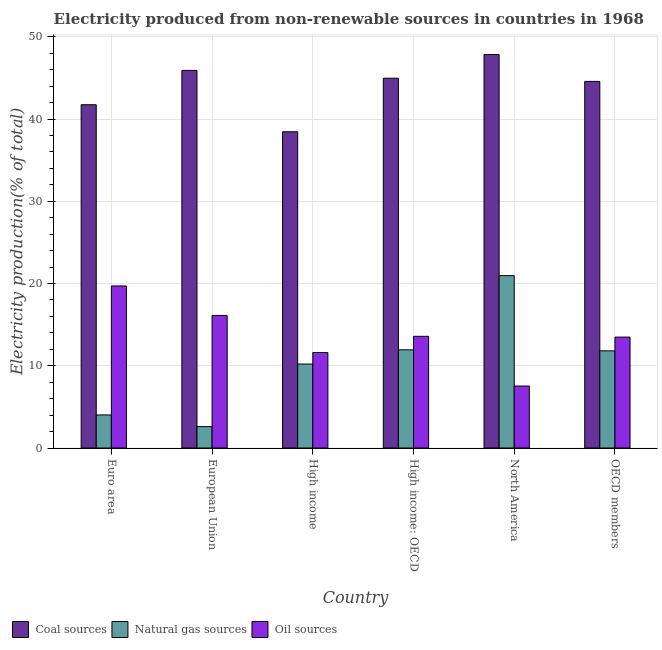How many different coloured bars are there?
Provide a short and direct response. 3. Are the number of bars per tick equal to the number of legend labels?
Offer a terse response. Yes. How many bars are there on the 2nd tick from the left?
Your response must be concise. 3. How many bars are there on the 1st tick from the right?
Your answer should be compact. 3. In how many cases, is the number of bars for a given country not equal to the number of legend labels?
Ensure brevity in your answer.  0. What is the percentage of electricity produced by natural gas in OECD members?
Your answer should be very brief. 11.82. Across all countries, what is the maximum percentage of electricity produced by coal?
Give a very brief answer. 47.84. Across all countries, what is the minimum percentage of electricity produced by natural gas?
Ensure brevity in your answer.  2.6. What is the total percentage of electricity produced by natural gas in the graph?
Offer a very short reply. 61.54. What is the difference between the percentage of electricity produced by coal in Euro area and that in OECD members?
Provide a succinct answer. -2.84. What is the difference between the percentage of electricity produced by coal in High income and the percentage of electricity produced by natural gas in North America?
Make the answer very short. 17.49. What is the average percentage of electricity produced by coal per country?
Give a very brief answer. 43.91. What is the difference between the percentage of electricity produced by oil sources and percentage of electricity produced by coal in High income: OECD?
Keep it short and to the point. -31.38. What is the ratio of the percentage of electricity produced by coal in North America to that in OECD members?
Give a very brief answer. 1.07. What is the difference between the highest and the second highest percentage of electricity produced by oil sources?
Make the answer very short. 3.59. What is the difference between the highest and the lowest percentage of electricity produced by natural gas?
Give a very brief answer. 18.35. What does the 1st bar from the left in High income: OECD represents?
Make the answer very short. Coal sources. What does the 2nd bar from the right in North America represents?
Provide a short and direct response. Natural gas sources. Is it the case that in every country, the sum of the percentage of electricity produced by coal and percentage of electricity produced by natural gas is greater than the percentage of electricity produced by oil sources?
Provide a short and direct response. Yes. How many countries are there in the graph?
Your answer should be very brief. 6. Are the values on the major ticks of Y-axis written in scientific E-notation?
Give a very brief answer. No. Where does the legend appear in the graph?
Give a very brief answer. Bottom left. How many legend labels are there?
Your response must be concise. 3. What is the title of the graph?
Offer a very short reply. Electricity produced from non-renewable sources in countries in 1968. What is the label or title of the Y-axis?
Give a very brief answer. Electricity production(% of total). What is the Electricity production(% of total) in Coal sources in Euro area?
Your answer should be compact. 41.74. What is the Electricity production(% of total) of Natural gas sources in Euro area?
Your response must be concise. 4.02. What is the Electricity production(% of total) of Oil sources in Euro area?
Ensure brevity in your answer.  19.7. What is the Electricity production(% of total) of Coal sources in European Union?
Provide a short and direct response. 45.91. What is the Electricity production(% of total) of Natural gas sources in European Union?
Keep it short and to the point. 2.6. What is the Electricity production(% of total) of Oil sources in European Union?
Offer a very short reply. 16.12. What is the Electricity production(% of total) of Coal sources in High income?
Keep it short and to the point. 38.45. What is the Electricity production(% of total) of Natural gas sources in High income?
Keep it short and to the point. 10.21. What is the Electricity production(% of total) of Oil sources in High income?
Your answer should be compact. 11.61. What is the Electricity production(% of total) in Coal sources in High income: OECD?
Give a very brief answer. 44.96. What is the Electricity production(% of total) of Natural gas sources in High income: OECD?
Give a very brief answer. 11.94. What is the Electricity production(% of total) in Oil sources in High income: OECD?
Your response must be concise. 13.58. What is the Electricity production(% of total) of Coal sources in North America?
Ensure brevity in your answer.  47.84. What is the Electricity production(% of total) in Natural gas sources in North America?
Offer a terse response. 20.96. What is the Electricity production(% of total) of Oil sources in North America?
Provide a succinct answer. 7.54. What is the Electricity production(% of total) of Coal sources in OECD members?
Your answer should be compact. 44.57. What is the Electricity production(% of total) in Natural gas sources in OECD members?
Provide a succinct answer. 11.82. What is the Electricity production(% of total) of Oil sources in OECD members?
Keep it short and to the point. 13.48. Across all countries, what is the maximum Electricity production(% of total) in Coal sources?
Ensure brevity in your answer.  47.84. Across all countries, what is the maximum Electricity production(% of total) in Natural gas sources?
Your answer should be compact. 20.96. Across all countries, what is the maximum Electricity production(% of total) in Oil sources?
Keep it short and to the point. 19.7. Across all countries, what is the minimum Electricity production(% of total) in Coal sources?
Give a very brief answer. 38.45. Across all countries, what is the minimum Electricity production(% of total) of Natural gas sources?
Your answer should be compact. 2.6. Across all countries, what is the minimum Electricity production(% of total) in Oil sources?
Offer a terse response. 7.54. What is the total Electricity production(% of total) in Coal sources in the graph?
Offer a terse response. 263.48. What is the total Electricity production(% of total) of Natural gas sources in the graph?
Your response must be concise. 61.54. What is the total Electricity production(% of total) in Oil sources in the graph?
Your answer should be compact. 82.03. What is the difference between the Electricity production(% of total) in Coal sources in Euro area and that in European Union?
Give a very brief answer. -4.17. What is the difference between the Electricity production(% of total) of Natural gas sources in Euro area and that in European Union?
Give a very brief answer. 1.42. What is the difference between the Electricity production(% of total) of Oil sources in Euro area and that in European Union?
Make the answer very short. 3.59. What is the difference between the Electricity production(% of total) in Coal sources in Euro area and that in High income?
Keep it short and to the point. 3.29. What is the difference between the Electricity production(% of total) of Natural gas sources in Euro area and that in High income?
Keep it short and to the point. -6.19. What is the difference between the Electricity production(% of total) of Oil sources in Euro area and that in High income?
Offer a very short reply. 8.09. What is the difference between the Electricity production(% of total) in Coal sources in Euro area and that in High income: OECD?
Your answer should be compact. -3.22. What is the difference between the Electricity production(% of total) in Natural gas sources in Euro area and that in High income: OECD?
Offer a very short reply. -7.92. What is the difference between the Electricity production(% of total) of Oil sources in Euro area and that in High income: OECD?
Your response must be concise. 6.12. What is the difference between the Electricity production(% of total) of Coal sources in Euro area and that in North America?
Ensure brevity in your answer.  -6.1. What is the difference between the Electricity production(% of total) of Natural gas sources in Euro area and that in North America?
Ensure brevity in your answer.  -16.94. What is the difference between the Electricity production(% of total) in Oil sources in Euro area and that in North America?
Your response must be concise. 12.17. What is the difference between the Electricity production(% of total) of Coal sources in Euro area and that in OECD members?
Give a very brief answer. -2.84. What is the difference between the Electricity production(% of total) of Natural gas sources in Euro area and that in OECD members?
Provide a short and direct response. -7.8. What is the difference between the Electricity production(% of total) of Oil sources in Euro area and that in OECD members?
Make the answer very short. 6.22. What is the difference between the Electricity production(% of total) in Coal sources in European Union and that in High income?
Give a very brief answer. 7.46. What is the difference between the Electricity production(% of total) in Natural gas sources in European Union and that in High income?
Ensure brevity in your answer.  -7.61. What is the difference between the Electricity production(% of total) of Oil sources in European Union and that in High income?
Offer a very short reply. 4.5. What is the difference between the Electricity production(% of total) in Coal sources in European Union and that in High income: OECD?
Provide a short and direct response. 0.95. What is the difference between the Electricity production(% of total) of Natural gas sources in European Union and that in High income: OECD?
Ensure brevity in your answer.  -9.34. What is the difference between the Electricity production(% of total) in Oil sources in European Union and that in High income: OECD?
Offer a terse response. 2.54. What is the difference between the Electricity production(% of total) of Coal sources in European Union and that in North America?
Provide a short and direct response. -1.93. What is the difference between the Electricity production(% of total) of Natural gas sources in European Union and that in North America?
Your answer should be compact. -18.35. What is the difference between the Electricity production(% of total) in Oil sources in European Union and that in North America?
Your response must be concise. 8.58. What is the difference between the Electricity production(% of total) of Coal sources in European Union and that in OECD members?
Provide a short and direct response. 1.34. What is the difference between the Electricity production(% of total) in Natural gas sources in European Union and that in OECD members?
Your response must be concise. -9.21. What is the difference between the Electricity production(% of total) in Oil sources in European Union and that in OECD members?
Give a very brief answer. 2.63. What is the difference between the Electricity production(% of total) in Coal sources in High income and that in High income: OECD?
Offer a terse response. -6.51. What is the difference between the Electricity production(% of total) of Natural gas sources in High income and that in High income: OECD?
Your answer should be very brief. -1.73. What is the difference between the Electricity production(% of total) of Oil sources in High income and that in High income: OECD?
Make the answer very short. -1.97. What is the difference between the Electricity production(% of total) in Coal sources in High income and that in North America?
Your response must be concise. -9.39. What is the difference between the Electricity production(% of total) in Natural gas sources in High income and that in North America?
Your response must be concise. -10.75. What is the difference between the Electricity production(% of total) of Oil sources in High income and that in North America?
Ensure brevity in your answer.  4.08. What is the difference between the Electricity production(% of total) of Coal sources in High income and that in OECD members?
Make the answer very short. -6.12. What is the difference between the Electricity production(% of total) of Natural gas sources in High income and that in OECD members?
Give a very brief answer. -1.61. What is the difference between the Electricity production(% of total) of Oil sources in High income and that in OECD members?
Provide a short and direct response. -1.87. What is the difference between the Electricity production(% of total) of Coal sources in High income: OECD and that in North America?
Keep it short and to the point. -2.88. What is the difference between the Electricity production(% of total) of Natural gas sources in High income: OECD and that in North America?
Keep it short and to the point. -9.02. What is the difference between the Electricity production(% of total) in Oil sources in High income: OECD and that in North America?
Provide a short and direct response. 6.04. What is the difference between the Electricity production(% of total) of Coal sources in High income: OECD and that in OECD members?
Offer a very short reply. 0.39. What is the difference between the Electricity production(% of total) in Natural gas sources in High income: OECD and that in OECD members?
Your answer should be very brief. 0.12. What is the difference between the Electricity production(% of total) of Oil sources in High income: OECD and that in OECD members?
Offer a very short reply. 0.1. What is the difference between the Electricity production(% of total) in Coal sources in North America and that in OECD members?
Make the answer very short. 3.27. What is the difference between the Electricity production(% of total) in Natural gas sources in North America and that in OECD members?
Keep it short and to the point. 9.14. What is the difference between the Electricity production(% of total) in Oil sources in North America and that in OECD members?
Your answer should be compact. -5.95. What is the difference between the Electricity production(% of total) of Coal sources in Euro area and the Electricity production(% of total) of Natural gas sources in European Union?
Provide a succinct answer. 39.14. What is the difference between the Electricity production(% of total) of Coal sources in Euro area and the Electricity production(% of total) of Oil sources in European Union?
Keep it short and to the point. 25.62. What is the difference between the Electricity production(% of total) of Natural gas sources in Euro area and the Electricity production(% of total) of Oil sources in European Union?
Your response must be concise. -12.1. What is the difference between the Electricity production(% of total) of Coal sources in Euro area and the Electricity production(% of total) of Natural gas sources in High income?
Offer a terse response. 31.53. What is the difference between the Electricity production(% of total) of Coal sources in Euro area and the Electricity production(% of total) of Oil sources in High income?
Your answer should be compact. 30.13. What is the difference between the Electricity production(% of total) of Natural gas sources in Euro area and the Electricity production(% of total) of Oil sources in High income?
Your answer should be compact. -7.59. What is the difference between the Electricity production(% of total) of Coal sources in Euro area and the Electricity production(% of total) of Natural gas sources in High income: OECD?
Your response must be concise. 29.8. What is the difference between the Electricity production(% of total) of Coal sources in Euro area and the Electricity production(% of total) of Oil sources in High income: OECD?
Your answer should be very brief. 28.16. What is the difference between the Electricity production(% of total) in Natural gas sources in Euro area and the Electricity production(% of total) in Oil sources in High income: OECD?
Give a very brief answer. -9.56. What is the difference between the Electricity production(% of total) of Coal sources in Euro area and the Electricity production(% of total) of Natural gas sources in North America?
Offer a very short reply. 20.78. What is the difference between the Electricity production(% of total) of Coal sources in Euro area and the Electricity production(% of total) of Oil sources in North America?
Give a very brief answer. 34.2. What is the difference between the Electricity production(% of total) in Natural gas sources in Euro area and the Electricity production(% of total) in Oil sources in North America?
Your answer should be compact. -3.52. What is the difference between the Electricity production(% of total) in Coal sources in Euro area and the Electricity production(% of total) in Natural gas sources in OECD members?
Ensure brevity in your answer.  29.92. What is the difference between the Electricity production(% of total) of Coal sources in Euro area and the Electricity production(% of total) of Oil sources in OECD members?
Your answer should be very brief. 28.25. What is the difference between the Electricity production(% of total) in Natural gas sources in Euro area and the Electricity production(% of total) in Oil sources in OECD members?
Offer a very short reply. -9.47. What is the difference between the Electricity production(% of total) in Coal sources in European Union and the Electricity production(% of total) in Natural gas sources in High income?
Your response must be concise. 35.7. What is the difference between the Electricity production(% of total) in Coal sources in European Union and the Electricity production(% of total) in Oil sources in High income?
Your answer should be compact. 34.3. What is the difference between the Electricity production(% of total) of Natural gas sources in European Union and the Electricity production(% of total) of Oil sources in High income?
Make the answer very short. -9.01. What is the difference between the Electricity production(% of total) of Coal sources in European Union and the Electricity production(% of total) of Natural gas sources in High income: OECD?
Your response must be concise. 33.97. What is the difference between the Electricity production(% of total) in Coal sources in European Union and the Electricity production(% of total) in Oil sources in High income: OECD?
Offer a very short reply. 32.33. What is the difference between the Electricity production(% of total) in Natural gas sources in European Union and the Electricity production(% of total) in Oil sources in High income: OECD?
Your response must be concise. -10.98. What is the difference between the Electricity production(% of total) of Coal sources in European Union and the Electricity production(% of total) of Natural gas sources in North America?
Keep it short and to the point. 24.95. What is the difference between the Electricity production(% of total) of Coal sources in European Union and the Electricity production(% of total) of Oil sources in North America?
Your response must be concise. 38.38. What is the difference between the Electricity production(% of total) of Natural gas sources in European Union and the Electricity production(% of total) of Oil sources in North America?
Your answer should be very brief. -4.93. What is the difference between the Electricity production(% of total) of Coal sources in European Union and the Electricity production(% of total) of Natural gas sources in OECD members?
Keep it short and to the point. 34.1. What is the difference between the Electricity production(% of total) in Coal sources in European Union and the Electricity production(% of total) in Oil sources in OECD members?
Provide a short and direct response. 32.43. What is the difference between the Electricity production(% of total) in Natural gas sources in European Union and the Electricity production(% of total) in Oil sources in OECD members?
Provide a succinct answer. -10.88. What is the difference between the Electricity production(% of total) of Coal sources in High income and the Electricity production(% of total) of Natural gas sources in High income: OECD?
Ensure brevity in your answer.  26.51. What is the difference between the Electricity production(% of total) of Coal sources in High income and the Electricity production(% of total) of Oil sources in High income: OECD?
Your answer should be very brief. 24.87. What is the difference between the Electricity production(% of total) of Natural gas sources in High income and the Electricity production(% of total) of Oil sources in High income: OECD?
Offer a terse response. -3.37. What is the difference between the Electricity production(% of total) in Coal sources in High income and the Electricity production(% of total) in Natural gas sources in North America?
Your answer should be compact. 17.49. What is the difference between the Electricity production(% of total) in Coal sources in High income and the Electricity production(% of total) in Oil sources in North America?
Provide a short and direct response. 30.91. What is the difference between the Electricity production(% of total) in Natural gas sources in High income and the Electricity production(% of total) in Oil sources in North America?
Your answer should be very brief. 2.67. What is the difference between the Electricity production(% of total) of Coal sources in High income and the Electricity production(% of total) of Natural gas sources in OECD members?
Offer a terse response. 26.63. What is the difference between the Electricity production(% of total) of Coal sources in High income and the Electricity production(% of total) of Oil sources in OECD members?
Your response must be concise. 24.96. What is the difference between the Electricity production(% of total) in Natural gas sources in High income and the Electricity production(% of total) in Oil sources in OECD members?
Offer a very short reply. -3.28. What is the difference between the Electricity production(% of total) of Coal sources in High income: OECD and the Electricity production(% of total) of Natural gas sources in North America?
Provide a succinct answer. 24.01. What is the difference between the Electricity production(% of total) in Coal sources in High income: OECD and the Electricity production(% of total) in Oil sources in North America?
Provide a succinct answer. 37.43. What is the difference between the Electricity production(% of total) of Natural gas sources in High income: OECD and the Electricity production(% of total) of Oil sources in North America?
Offer a terse response. 4.4. What is the difference between the Electricity production(% of total) of Coal sources in High income: OECD and the Electricity production(% of total) of Natural gas sources in OECD members?
Your response must be concise. 33.15. What is the difference between the Electricity production(% of total) of Coal sources in High income: OECD and the Electricity production(% of total) of Oil sources in OECD members?
Provide a succinct answer. 31.48. What is the difference between the Electricity production(% of total) of Natural gas sources in High income: OECD and the Electricity production(% of total) of Oil sources in OECD members?
Provide a short and direct response. -1.55. What is the difference between the Electricity production(% of total) of Coal sources in North America and the Electricity production(% of total) of Natural gas sources in OECD members?
Give a very brief answer. 36.02. What is the difference between the Electricity production(% of total) of Coal sources in North America and the Electricity production(% of total) of Oil sources in OECD members?
Offer a terse response. 34.35. What is the difference between the Electricity production(% of total) of Natural gas sources in North America and the Electricity production(% of total) of Oil sources in OECD members?
Your response must be concise. 7.47. What is the average Electricity production(% of total) in Coal sources per country?
Make the answer very short. 43.91. What is the average Electricity production(% of total) of Natural gas sources per country?
Keep it short and to the point. 10.26. What is the average Electricity production(% of total) of Oil sources per country?
Your response must be concise. 13.67. What is the difference between the Electricity production(% of total) in Coal sources and Electricity production(% of total) in Natural gas sources in Euro area?
Provide a short and direct response. 37.72. What is the difference between the Electricity production(% of total) of Coal sources and Electricity production(% of total) of Oil sources in Euro area?
Offer a very short reply. 22.03. What is the difference between the Electricity production(% of total) in Natural gas sources and Electricity production(% of total) in Oil sources in Euro area?
Your answer should be very brief. -15.69. What is the difference between the Electricity production(% of total) of Coal sources and Electricity production(% of total) of Natural gas sources in European Union?
Make the answer very short. 43.31. What is the difference between the Electricity production(% of total) in Coal sources and Electricity production(% of total) in Oil sources in European Union?
Provide a succinct answer. 29.79. What is the difference between the Electricity production(% of total) of Natural gas sources and Electricity production(% of total) of Oil sources in European Union?
Give a very brief answer. -13.52. What is the difference between the Electricity production(% of total) of Coal sources and Electricity production(% of total) of Natural gas sources in High income?
Keep it short and to the point. 28.24. What is the difference between the Electricity production(% of total) of Coal sources and Electricity production(% of total) of Oil sources in High income?
Your answer should be compact. 26.84. What is the difference between the Electricity production(% of total) of Natural gas sources and Electricity production(% of total) of Oil sources in High income?
Provide a succinct answer. -1.4. What is the difference between the Electricity production(% of total) of Coal sources and Electricity production(% of total) of Natural gas sources in High income: OECD?
Offer a terse response. 33.02. What is the difference between the Electricity production(% of total) in Coal sources and Electricity production(% of total) in Oil sources in High income: OECD?
Ensure brevity in your answer.  31.38. What is the difference between the Electricity production(% of total) of Natural gas sources and Electricity production(% of total) of Oil sources in High income: OECD?
Offer a very short reply. -1.64. What is the difference between the Electricity production(% of total) of Coal sources and Electricity production(% of total) of Natural gas sources in North America?
Offer a terse response. 26.88. What is the difference between the Electricity production(% of total) of Coal sources and Electricity production(% of total) of Oil sources in North America?
Provide a succinct answer. 40.3. What is the difference between the Electricity production(% of total) of Natural gas sources and Electricity production(% of total) of Oil sources in North America?
Keep it short and to the point. 13.42. What is the difference between the Electricity production(% of total) of Coal sources and Electricity production(% of total) of Natural gas sources in OECD members?
Your response must be concise. 32.76. What is the difference between the Electricity production(% of total) of Coal sources and Electricity production(% of total) of Oil sources in OECD members?
Provide a short and direct response. 31.09. What is the difference between the Electricity production(% of total) in Natural gas sources and Electricity production(% of total) in Oil sources in OECD members?
Offer a terse response. -1.67. What is the ratio of the Electricity production(% of total) of Natural gas sources in Euro area to that in European Union?
Give a very brief answer. 1.54. What is the ratio of the Electricity production(% of total) of Oil sources in Euro area to that in European Union?
Offer a terse response. 1.22. What is the ratio of the Electricity production(% of total) in Coal sources in Euro area to that in High income?
Your response must be concise. 1.09. What is the ratio of the Electricity production(% of total) in Natural gas sources in Euro area to that in High income?
Give a very brief answer. 0.39. What is the ratio of the Electricity production(% of total) in Oil sources in Euro area to that in High income?
Your response must be concise. 1.7. What is the ratio of the Electricity production(% of total) of Coal sources in Euro area to that in High income: OECD?
Keep it short and to the point. 0.93. What is the ratio of the Electricity production(% of total) of Natural gas sources in Euro area to that in High income: OECD?
Keep it short and to the point. 0.34. What is the ratio of the Electricity production(% of total) in Oil sources in Euro area to that in High income: OECD?
Make the answer very short. 1.45. What is the ratio of the Electricity production(% of total) of Coal sources in Euro area to that in North America?
Your answer should be compact. 0.87. What is the ratio of the Electricity production(% of total) of Natural gas sources in Euro area to that in North America?
Provide a succinct answer. 0.19. What is the ratio of the Electricity production(% of total) in Oil sources in Euro area to that in North America?
Your answer should be compact. 2.61. What is the ratio of the Electricity production(% of total) of Coal sources in Euro area to that in OECD members?
Give a very brief answer. 0.94. What is the ratio of the Electricity production(% of total) of Natural gas sources in Euro area to that in OECD members?
Offer a very short reply. 0.34. What is the ratio of the Electricity production(% of total) in Oil sources in Euro area to that in OECD members?
Provide a succinct answer. 1.46. What is the ratio of the Electricity production(% of total) of Coal sources in European Union to that in High income?
Your response must be concise. 1.19. What is the ratio of the Electricity production(% of total) of Natural gas sources in European Union to that in High income?
Provide a short and direct response. 0.25. What is the ratio of the Electricity production(% of total) in Oil sources in European Union to that in High income?
Provide a succinct answer. 1.39. What is the ratio of the Electricity production(% of total) of Coal sources in European Union to that in High income: OECD?
Offer a very short reply. 1.02. What is the ratio of the Electricity production(% of total) of Natural gas sources in European Union to that in High income: OECD?
Give a very brief answer. 0.22. What is the ratio of the Electricity production(% of total) of Oil sources in European Union to that in High income: OECD?
Give a very brief answer. 1.19. What is the ratio of the Electricity production(% of total) of Coal sources in European Union to that in North America?
Ensure brevity in your answer.  0.96. What is the ratio of the Electricity production(% of total) of Natural gas sources in European Union to that in North America?
Your response must be concise. 0.12. What is the ratio of the Electricity production(% of total) of Oil sources in European Union to that in North America?
Ensure brevity in your answer.  2.14. What is the ratio of the Electricity production(% of total) in Natural gas sources in European Union to that in OECD members?
Provide a short and direct response. 0.22. What is the ratio of the Electricity production(% of total) in Oil sources in European Union to that in OECD members?
Provide a succinct answer. 1.2. What is the ratio of the Electricity production(% of total) in Coal sources in High income to that in High income: OECD?
Your answer should be compact. 0.86. What is the ratio of the Electricity production(% of total) of Natural gas sources in High income to that in High income: OECD?
Offer a terse response. 0.86. What is the ratio of the Electricity production(% of total) of Oil sources in High income to that in High income: OECD?
Your response must be concise. 0.86. What is the ratio of the Electricity production(% of total) in Coal sources in High income to that in North America?
Give a very brief answer. 0.8. What is the ratio of the Electricity production(% of total) in Natural gas sources in High income to that in North America?
Your response must be concise. 0.49. What is the ratio of the Electricity production(% of total) in Oil sources in High income to that in North America?
Offer a very short reply. 1.54. What is the ratio of the Electricity production(% of total) in Coal sources in High income to that in OECD members?
Your response must be concise. 0.86. What is the ratio of the Electricity production(% of total) in Natural gas sources in High income to that in OECD members?
Offer a terse response. 0.86. What is the ratio of the Electricity production(% of total) of Oil sources in High income to that in OECD members?
Make the answer very short. 0.86. What is the ratio of the Electricity production(% of total) of Coal sources in High income: OECD to that in North America?
Your answer should be very brief. 0.94. What is the ratio of the Electricity production(% of total) in Natural gas sources in High income: OECD to that in North America?
Your answer should be very brief. 0.57. What is the ratio of the Electricity production(% of total) of Oil sources in High income: OECD to that in North America?
Provide a succinct answer. 1.8. What is the ratio of the Electricity production(% of total) in Coal sources in High income: OECD to that in OECD members?
Provide a short and direct response. 1.01. What is the ratio of the Electricity production(% of total) in Natural gas sources in High income: OECD to that in OECD members?
Your response must be concise. 1.01. What is the ratio of the Electricity production(% of total) in Oil sources in High income: OECD to that in OECD members?
Ensure brevity in your answer.  1.01. What is the ratio of the Electricity production(% of total) of Coal sources in North America to that in OECD members?
Your response must be concise. 1.07. What is the ratio of the Electricity production(% of total) in Natural gas sources in North America to that in OECD members?
Provide a short and direct response. 1.77. What is the ratio of the Electricity production(% of total) in Oil sources in North America to that in OECD members?
Provide a succinct answer. 0.56. What is the difference between the highest and the second highest Electricity production(% of total) in Coal sources?
Your answer should be compact. 1.93. What is the difference between the highest and the second highest Electricity production(% of total) of Natural gas sources?
Ensure brevity in your answer.  9.02. What is the difference between the highest and the second highest Electricity production(% of total) of Oil sources?
Your answer should be compact. 3.59. What is the difference between the highest and the lowest Electricity production(% of total) of Coal sources?
Ensure brevity in your answer.  9.39. What is the difference between the highest and the lowest Electricity production(% of total) of Natural gas sources?
Provide a short and direct response. 18.35. What is the difference between the highest and the lowest Electricity production(% of total) in Oil sources?
Give a very brief answer. 12.17. 